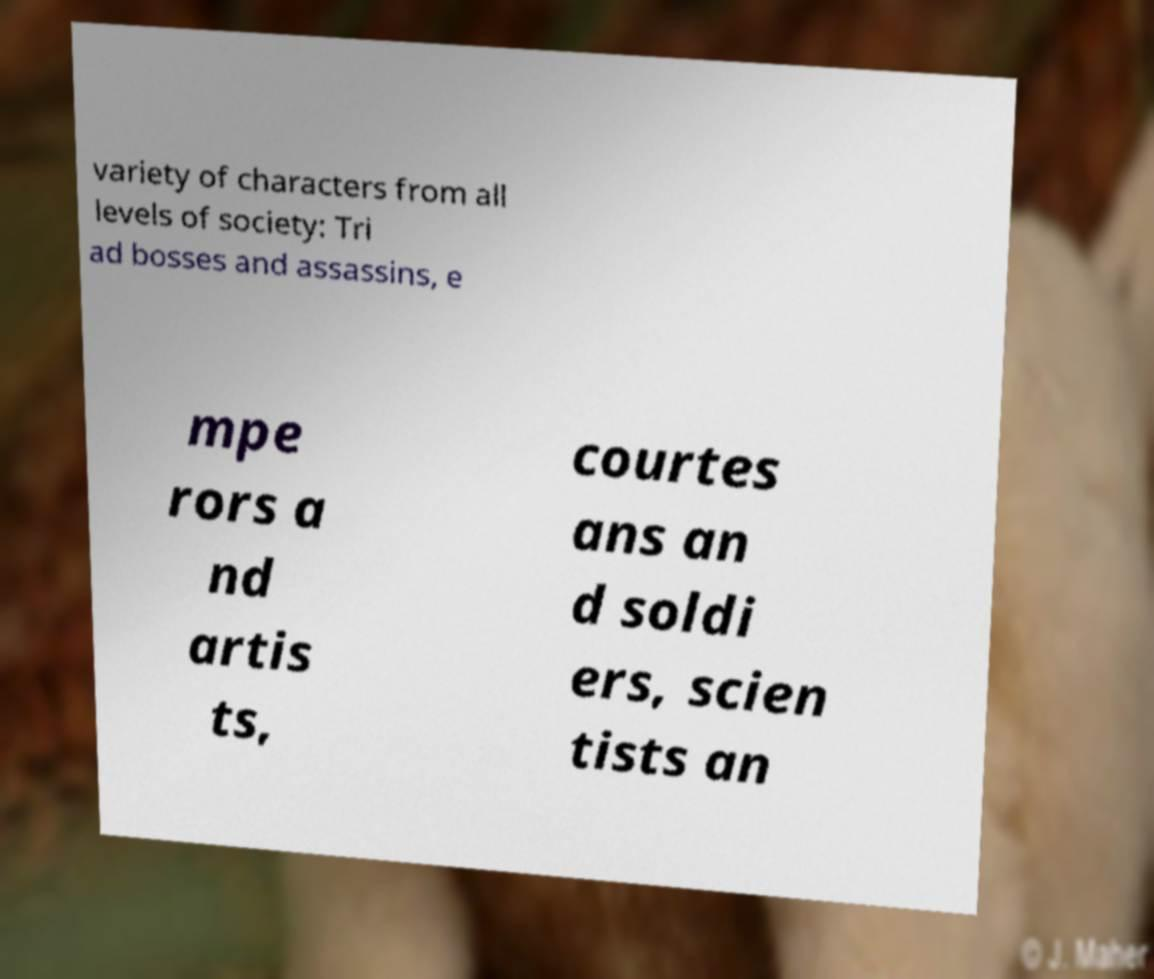Please read and relay the text visible in this image. What does it say? variety of characters from all levels of society: Tri ad bosses and assassins, e mpe rors a nd artis ts, courtes ans an d soldi ers, scien tists an 